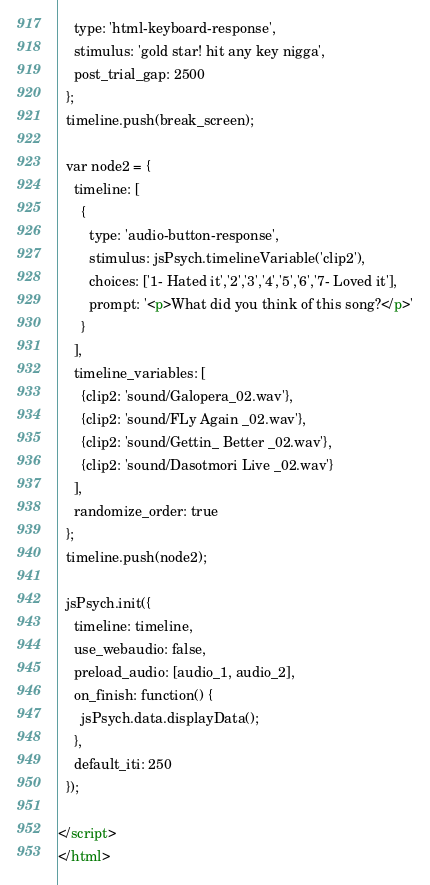<code> <loc_0><loc_0><loc_500><loc_500><_HTML_>    type: 'html-keyboard-response',
    stimulus: 'gold star! hit any key nigga',
    post_trial_gap: 2500
  };
  timeline.push(break_screen);

  var node2 = {
    timeline: [
      {
        type: 'audio-button-response',
        stimulus: jsPsych.timelineVariable('clip2'),
        choices: ['1- Hated it','2','3','4','5','6','7- Loved it'],
        prompt: '<p>What did you think of this song?</p>'
      }
    ],
    timeline_variables: [
      {clip2: 'sound/Galopera_02.wav'},
      {clip2: 'sound/FLy Again _02.wav'},
      {clip2: 'sound/Gettin_ Better _02.wav'},
      {clip2: 'sound/Dasotmori Live _02.wav'}
    ],
    randomize_order: true
  };
  timeline.push(node2);

  jsPsych.init({
    timeline: timeline,
    use_webaudio: false,
    preload_audio: [audio_1, audio_2],
    on_finish: function() {
      jsPsych.data.displayData();
    },
    default_iti: 250
  });

</script>
</html>
</code> 